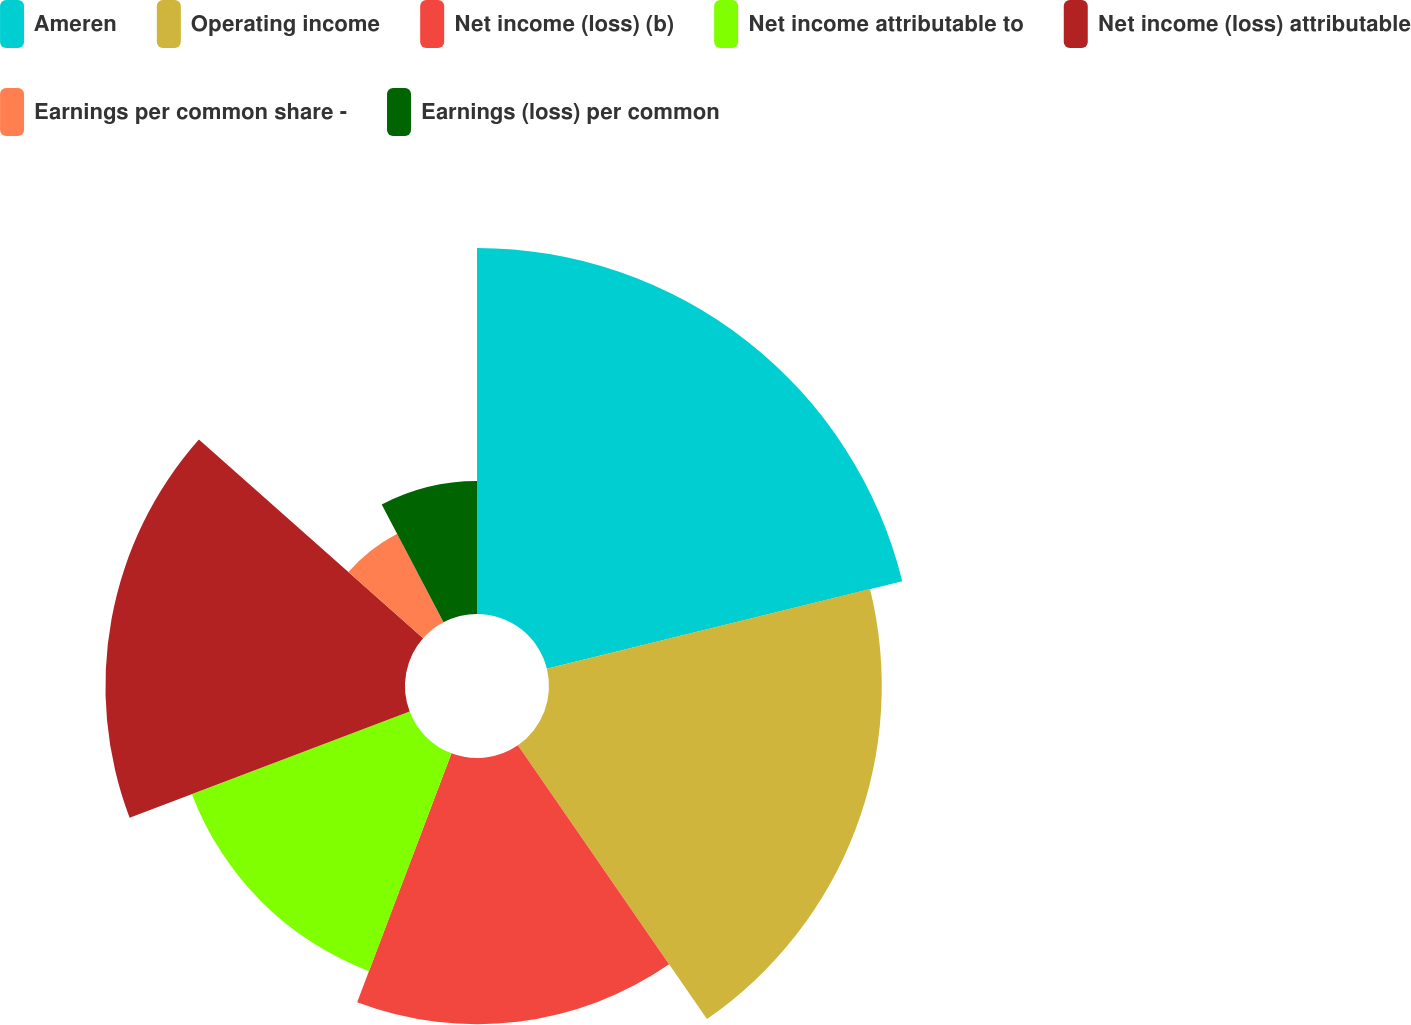Convert chart to OTSL. <chart><loc_0><loc_0><loc_500><loc_500><pie_chart><fcel>Ameren<fcel>Operating income<fcel>Net income (loss) (b)<fcel>Net income attributable to<fcel>Net income (loss) attributable<fcel>Earnings per common share -<fcel>Earnings (loss) per common<nl><fcel>21.15%<fcel>19.23%<fcel>15.38%<fcel>13.46%<fcel>17.31%<fcel>5.77%<fcel>7.69%<nl></chart> 